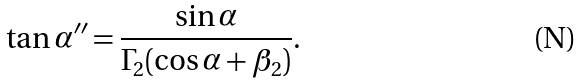Convert formula to latex. <formula><loc_0><loc_0><loc_500><loc_500>\tan \alpha ^ { \prime \prime } = \frac { \sin \alpha } { \Gamma _ { 2 } ( \cos \alpha + \beta _ { 2 } ) } .</formula> 